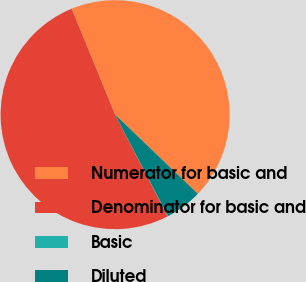Convert chart. <chart><loc_0><loc_0><loc_500><loc_500><pie_chart><fcel>Numerator for basic and<fcel>Denominator for basic and<fcel>Basic<fcel>Diluted<nl><fcel>43.34%<fcel>51.42%<fcel>0.06%<fcel>5.19%<nl></chart> 